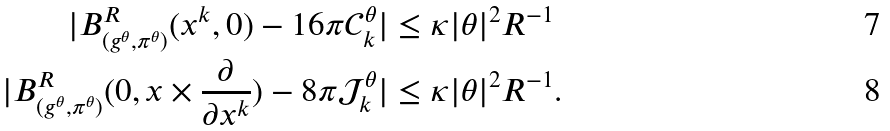Convert formula to latex. <formula><loc_0><loc_0><loc_500><loc_500>| B ^ { R } _ { ( g ^ { \theta } , \pi ^ { \theta } ) } ( x ^ { k } , 0 ) - 1 6 \pi \mathcal { C } ^ { \theta } _ { k } | & \leq \kappa | \theta | ^ { 2 } R ^ { - 1 } \\ | B ^ { R } _ { ( g ^ { \theta } , \pi ^ { \theta } ) } ( 0 , x \times \frac { \partial } { \partial x ^ { k } } ) - 8 \pi \mathcal { J } ^ { \theta } _ { k } | & \leq \kappa | \theta | ^ { 2 } R ^ { - 1 } .</formula> 